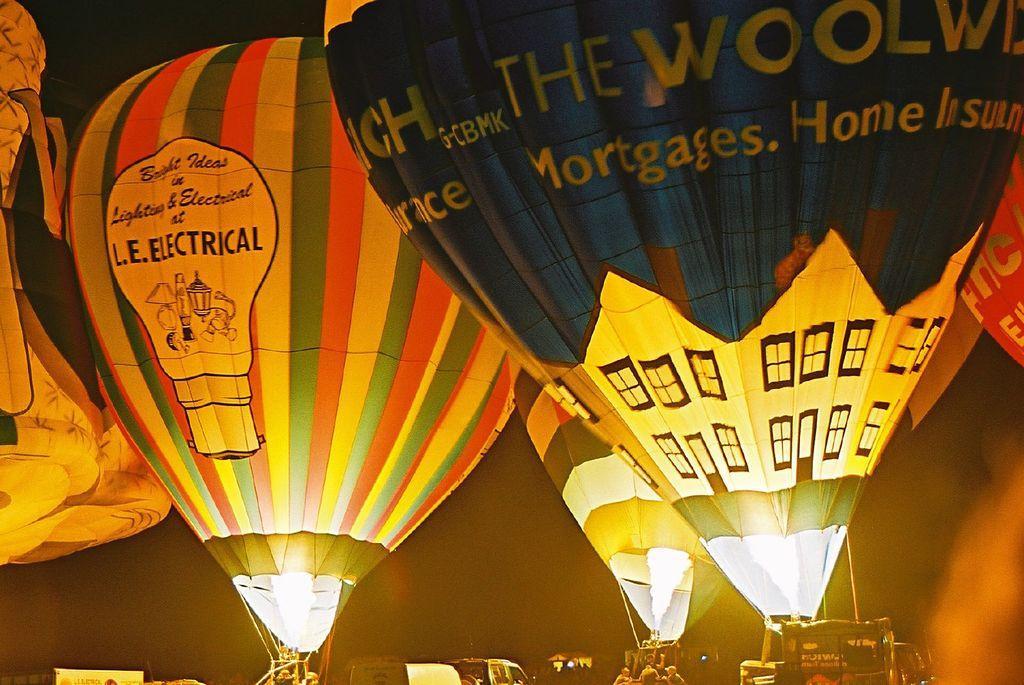How would you summarize this image in a sentence or two? In this image I can see the hot air balloons which are colorful. To the side of these people I can see few people and many vehicles. There is a black background. 